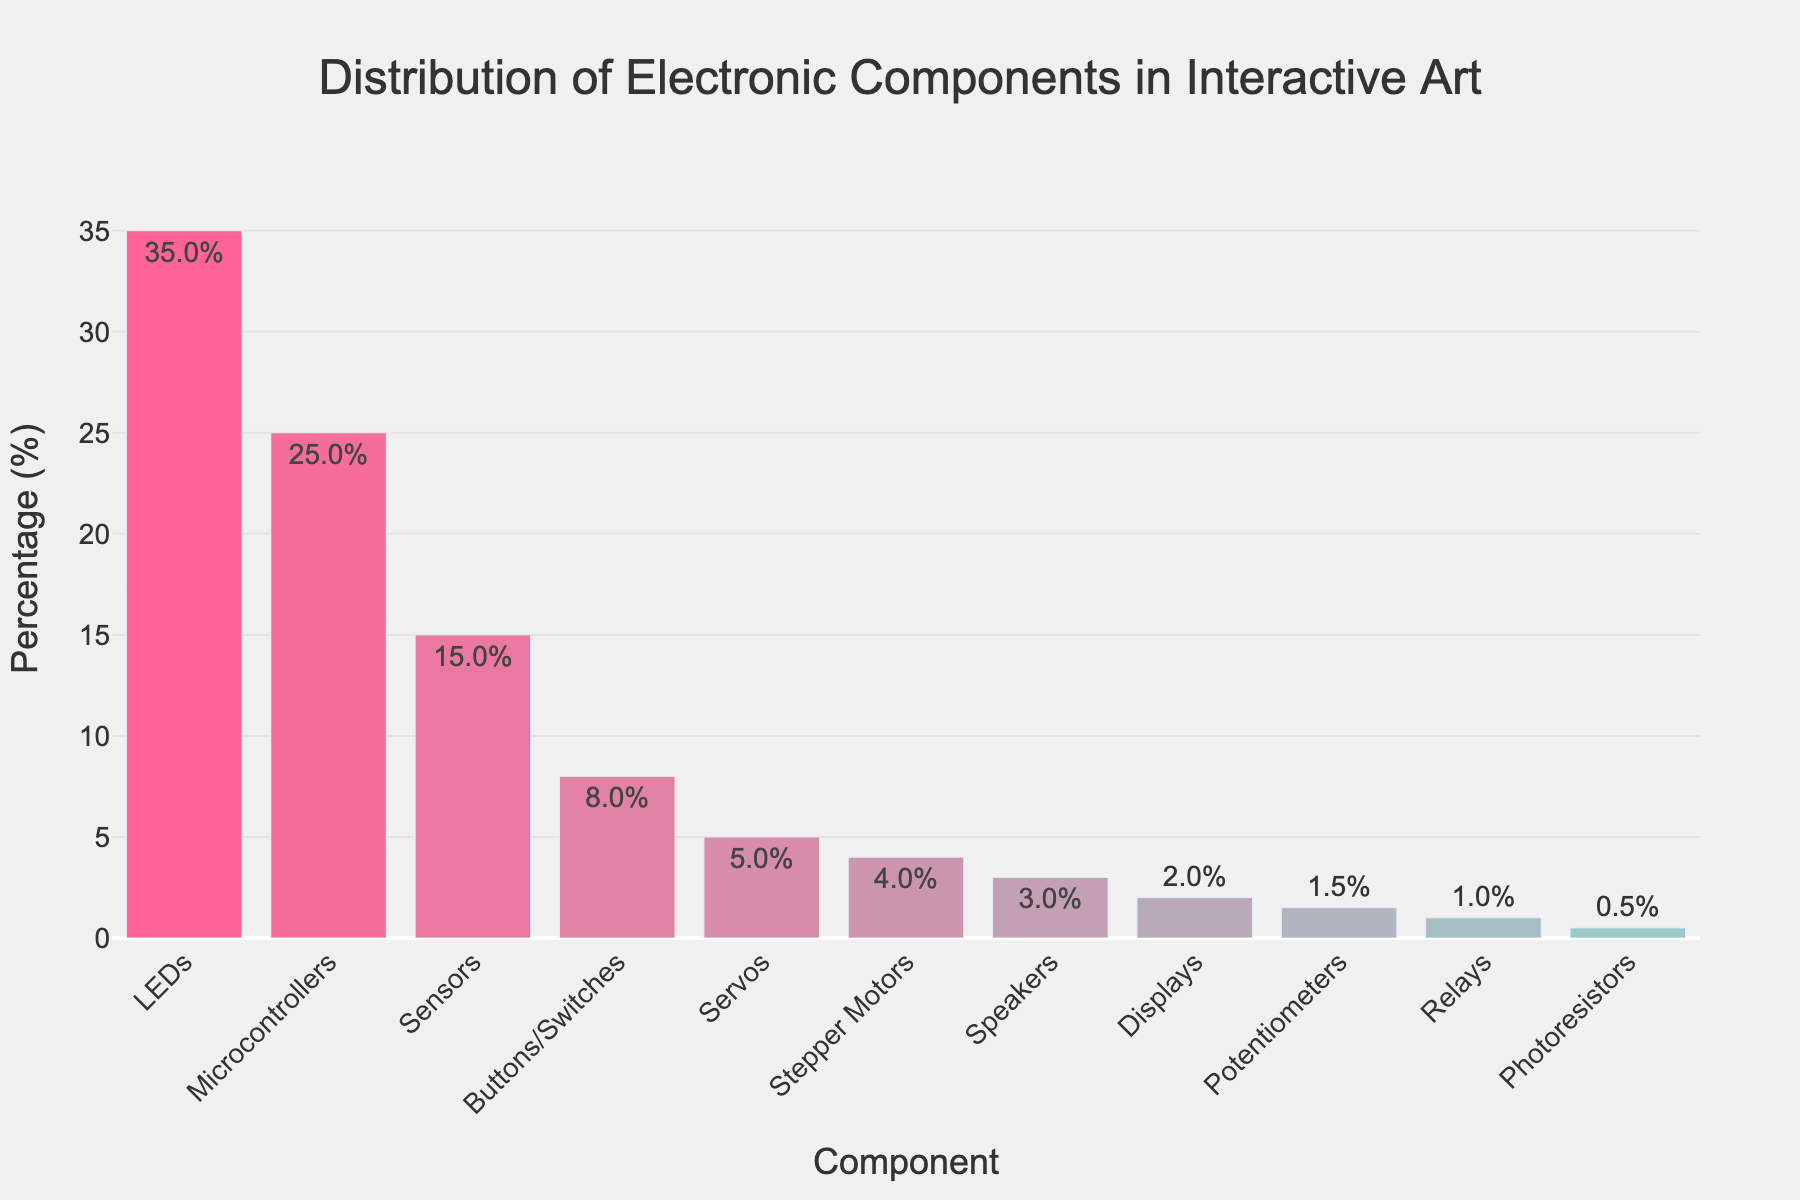Which electronic component is used the most in interactive art? By looking at the height of the bars, the bar representing LEDs is the tallest, indicating the highest percentage.
Answer: LEDs What is the total percentage of Sensors and Buttons/Switches combined? Sensors have 15% and Buttons/Switches have 8%. Summing these percentages gives 15% + 8% = 23%.
Answer: 23% How does the usage of Microcontrollers compare to that of Servos? Microcontrollers have a usage percentage of 25%, while Servos have 5%. Since 25% is greater than 5%, Microcontrollers are used more frequently.
Answer: Microcontrollers are used more frequently Which component has the smallest usage percentage and what is it? By looking at the height of the bars, the smallest bar represents Photoresistors, with a percentage of 0.5%.
Answer: Photoresistors, 0.5% Are Servos used more or less frequently than Buttons/Switches? Servos have a usage percentage of 5%, while Buttons/Switches have 8%. Since 5% is less than 8%, Servos are used less frequently.
Answer: Less frequently What is the percentage difference between the usage of LEDs and Stepper Motors? LEDs are used 35%, and Stepper Motors are used 4%. The difference is 35% - 4% = 31%.
Answer: 31% What is the average percentage usage of Displays and Potentiometers? Displays have 2% and Potentiometers have 1.5%. The average is (2% + 1.5%) / 2 = 1.75%.
Answer: 1.75% Which components have a usage percentage below 5%? By looking at the bar heights, the components below 5% are Stepper Motors (4%), Speakers (3%), Displays (2%), Potentiometers (1.5%), Relays (1%), and Photoresistors (0.5%).
Answer: Stepper Motors, Speakers, Displays, Potentiometers, Relays, Photoresistors How much greater is the usage of Microcontrollers compared to Sensors? Microcontrollers are used 25%, and Sensors are used 15%. The difference is 25% - 15% = 10%.
Answer: 10% What's the combined usage percentage for all components that have less than 2% usage? The components with less than 2% usage are Potentiometers (1.5%), Relays (1%), and Photoresistors (0.5%). The combined usage is 1.5% + 1% + 0.5% = 3%.
Answer: 3% 